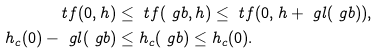<formula> <loc_0><loc_0><loc_500><loc_500>\ t f ( 0 , h ) & \leq \ t f ( \ g b , h ) \leq \ t f ( 0 , h + \ g l ( \ g b ) ) , \\ h _ { c } ( 0 ) - \ g l ( \ g b ) & \leq h _ { c } ( \ g b ) \leq h _ { c } ( 0 ) .</formula> 